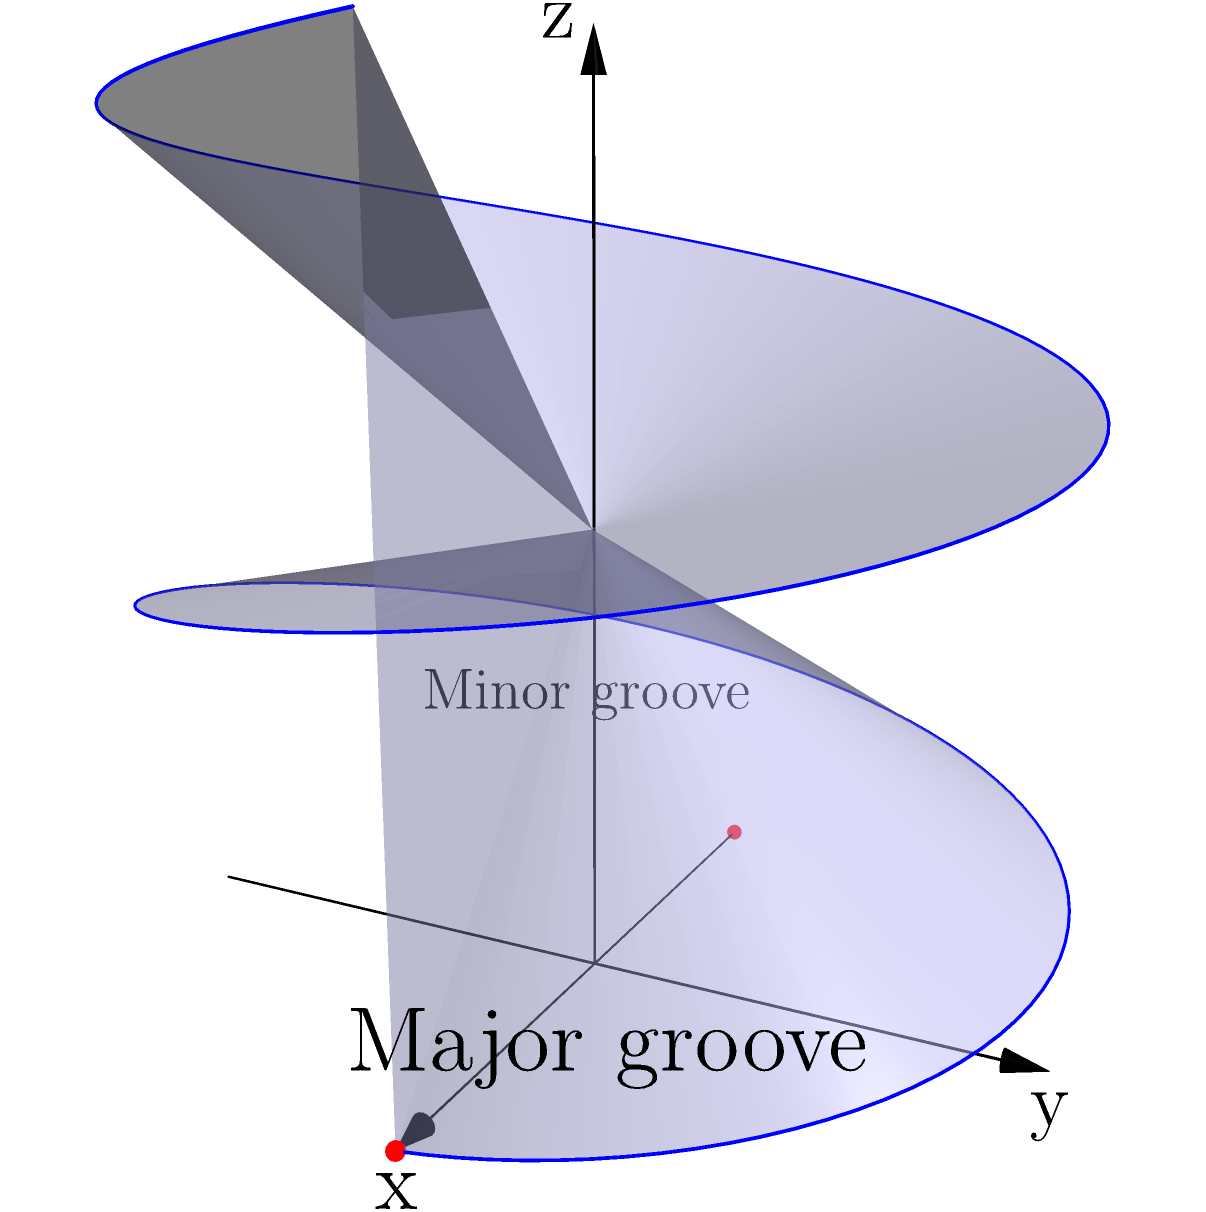In the DNA double helix structure shown, what is the significance of the major and minor grooves for drug interactions, and how does the helical geometry affect the binding of potential therapeutic molecules? To understand the significance of major and minor grooves in DNA for drug interactions, let's break it down step-by-step:

1. DNA Structure:
   The DNA double helix consists of two strands wound around each other, forming a spiral staircase-like structure.

2. Major and Minor Grooves:
   - The major groove is wider and deeper, as shown on the right side of the helix in the diagram.
   - The minor groove is narrower and shallower, as shown on the left side.

3. Accessibility:
   - The major groove provides more space and easier access to the base pairs.
   - The minor groove is more confined but still accessible to smaller molecules.

4. Binding Sites:
   - The grooves expose different parts of the base pairs, creating unique chemical environments.
   - This allows for specific recognition and binding of molecules.

5. Drug Interactions:
   - Many drugs and proteins preferentially bind to the major groove due to its size and accessibility.
   - Some smaller molecules, like certain antibiotics, can fit into and interact with the minor groove.

6. Helical Geometry Effects:
   - The helical structure creates a 3D landscape of potential binding sites.
   - One complete turn of the helix occurs approximately every 10-11 base pairs.
   - This geometry affects how molecules can approach and interact with the DNA.

7. Therapeutic Implications:
   - Understanding these structural features allows for the design of drugs that can specifically target certain DNA sequences.
   - The helical geometry can be exploited to create drugs that wrap around the DNA or fit precisely into grooves.

8. Examples:
   - Intercalating agents (like some chemotherapy drugs) can slip between base pairs, slightly unwinding the helix.
   - Groove binders can nestle into either the major or minor groove, depending on their size and shape.

In summary, the major and minor grooves provide distinct binding environments due to their different sizes and chemical exposures. The helical geometry of DNA creates a complex 3D structure that influences how potential therapeutic molecules can interact with and bind to specific sequences, which is crucial for drug design and function.
Answer: Major and minor grooves provide unique binding sites; helical geometry influences drug-DNA interactions by determining accessibility and specificity of binding. 